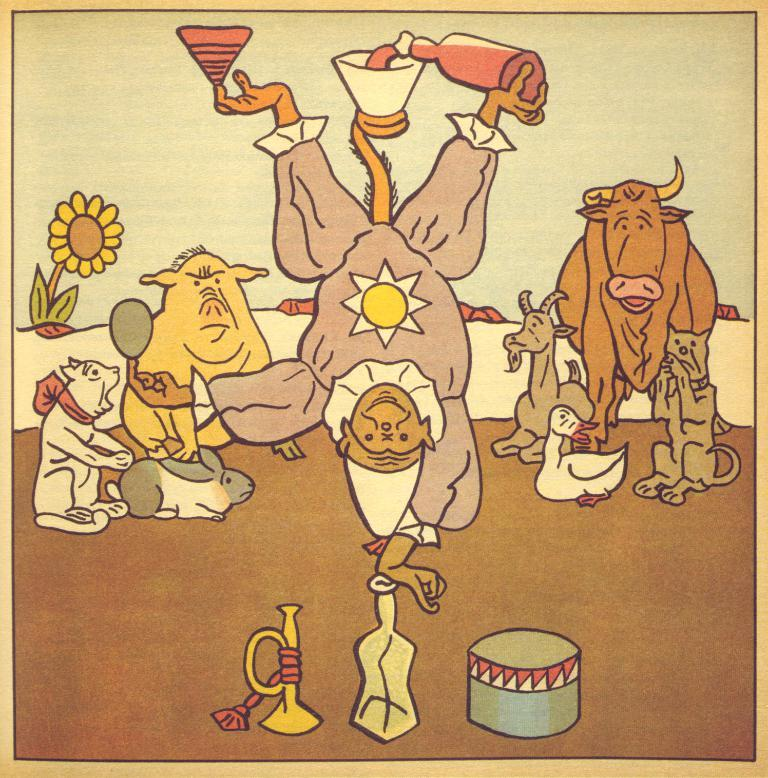What is the main subject of the image? The main subject of the image is a painting. What types of subjects are included in the painting? The painting includes a person, animals, a flower, and other objects. What is the medium of the painting? The painting is on a paper. What type of protest is depicted in the painting? There is no protest depicted in the painting; it includes a person, animals, a flower, and other objects. What is the shape of the square in the painting? There is no square present in the painting; it features a person, animals, a flower, and other objects on a paper. 